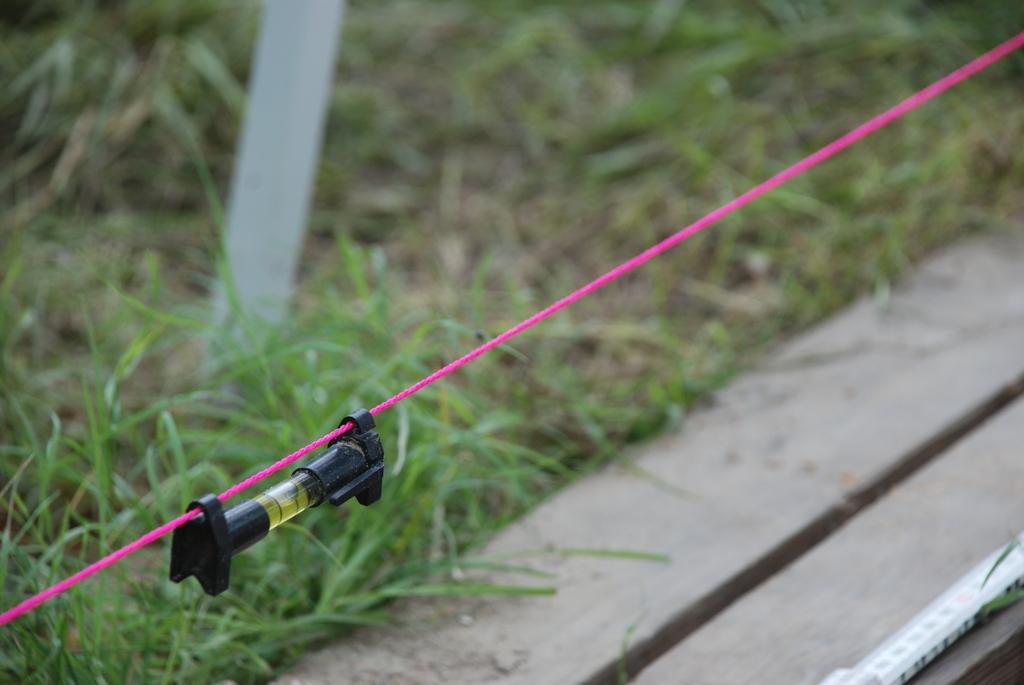Describe this image in one or two sentences. In this image I see the pink color rope on which there is a black color thing. In the background I see the green grass and I see the brown color thing over here and I see that it is blurred in the background and I see the white color thing over here. 